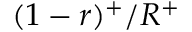Convert formula to latex. <formula><loc_0><loc_0><loc_500><loc_500>( 1 - r ) ^ { + } / R ^ { + }</formula> 